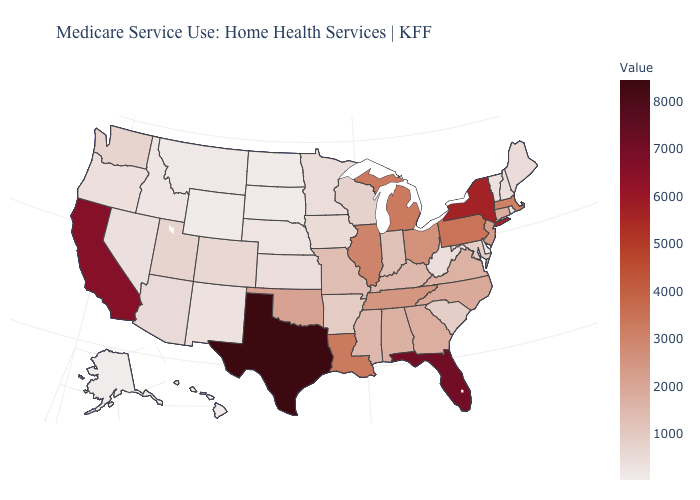Among the states that border Massachusetts , which have the lowest value?
Quick response, please. Rhode Island. Does Texas have a higher value than New Mexico?
Give a very brief answer. Yes. Does the map have missing data?
Quick response, please. No. Does Georgia have a lower value than Colorado?
Short answer required. No. Which states hav the highest value in the Northeast?
Short answer required. New York. 